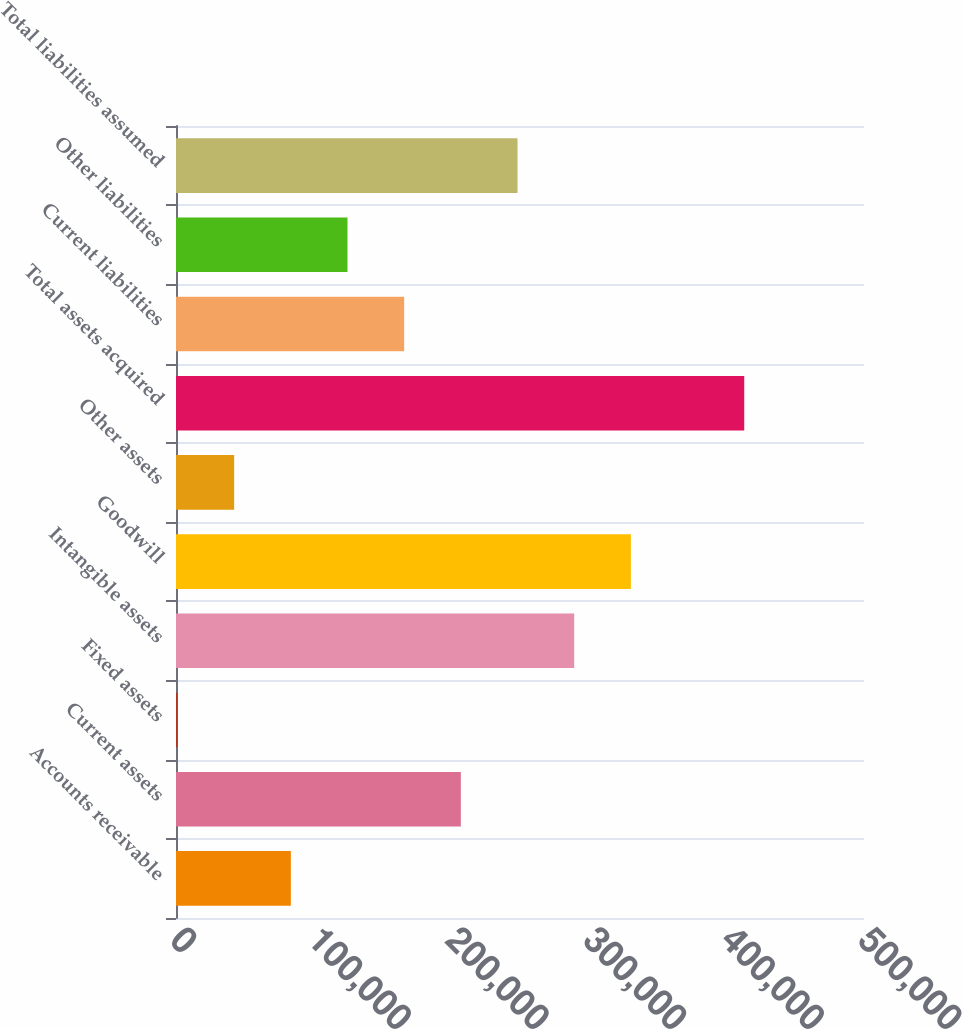Convert chart to OTSL. <chart><loc_0><loc_0><loc_500><loc_500><bar_chart><fcel>Accounts receivable<fcel>Current assets<fcel>Fixed assets<fcel>Intangible assets<fcel>Goodwill<fcel>Other assets<fcel>Total assets acquired<fcel>Current liabilities<fcel>Other liabilities<fcel>Total liabilities assumed<nl><fcel>83451.8<fcel>207017<fcel>1075<fcel>289394<fcel>330582<fcel>42263.4<fcel>412959<fcel>165829<fcel>124640<fcel>248205<nl></chart> 